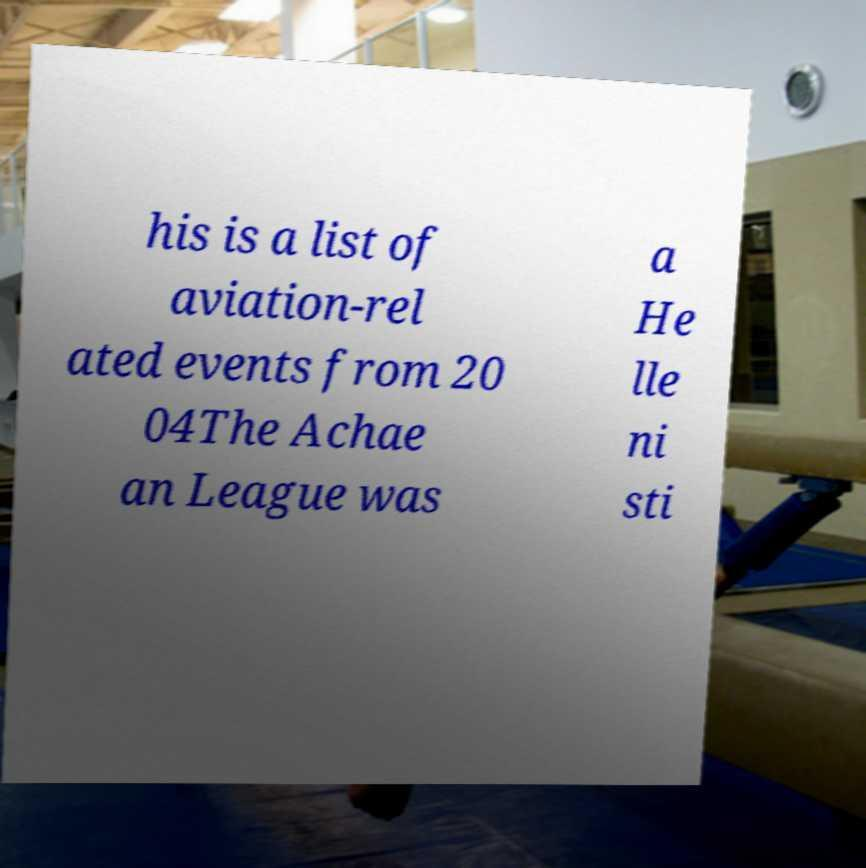What messages or text are displayed in this image? I need them in a readable, typed format. his is a list of aviation-rel ated events from 20 04The Achae an League was a He lle ni sti 